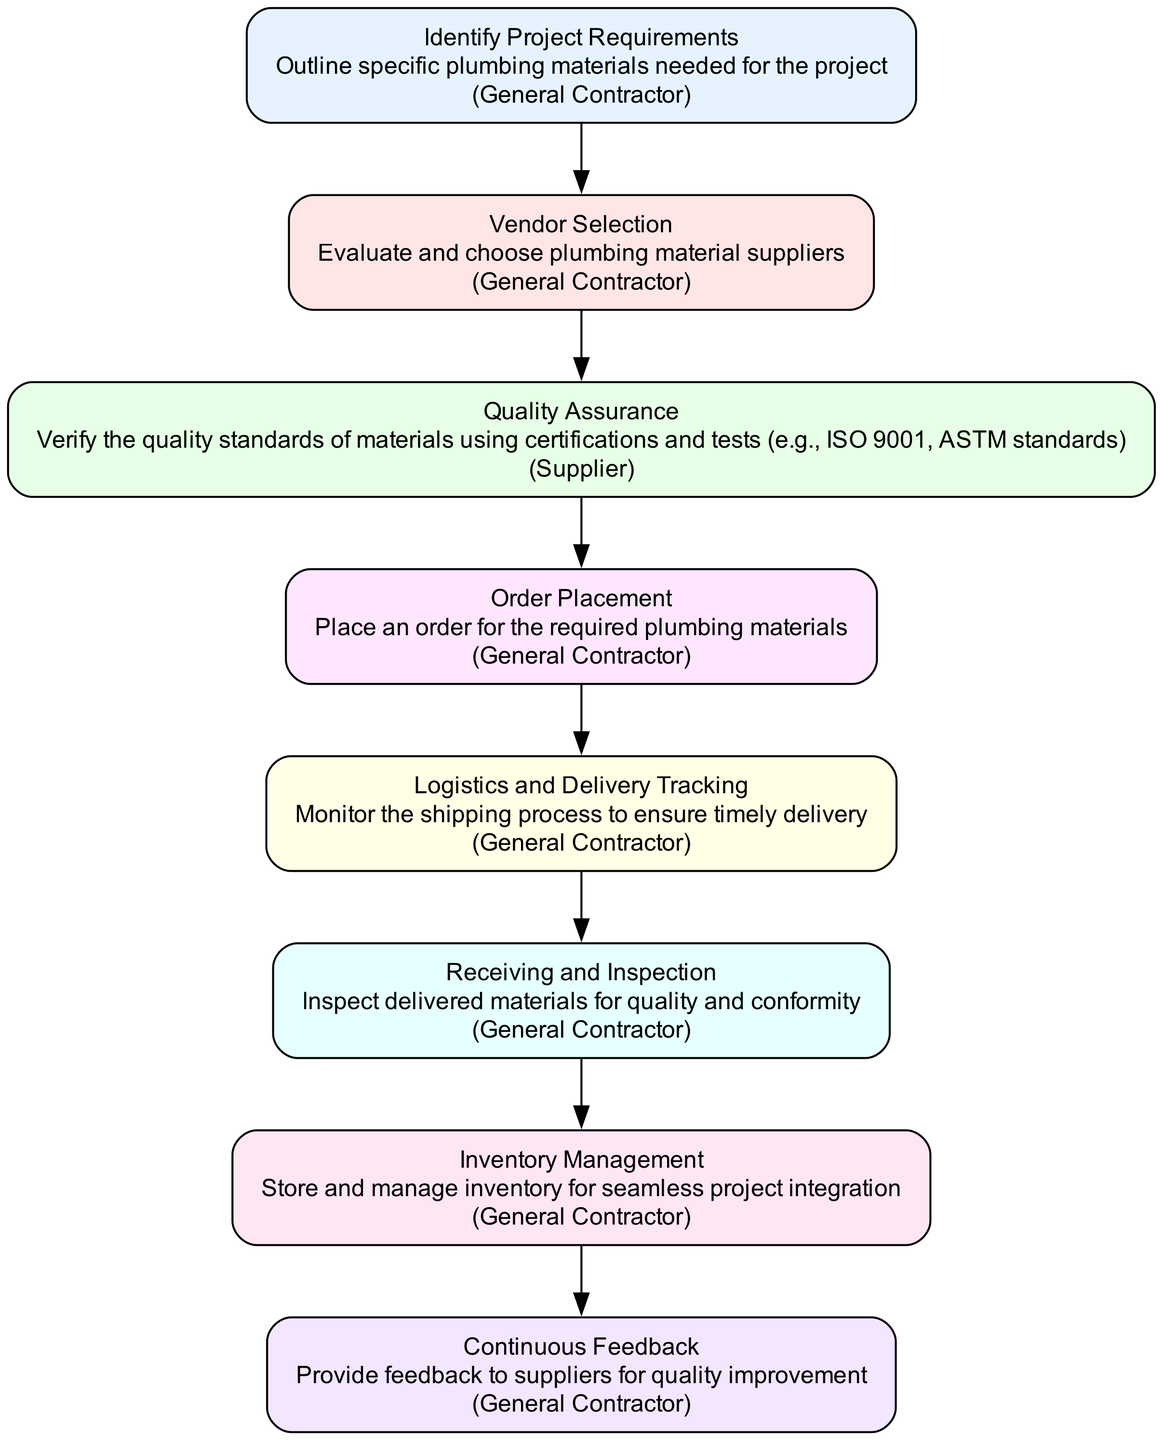What is the first step in the clinical pathway? The first step is labeled "Identify Project Requirements". It involves outlining specific plumbing materials needed for the project.
Answer: Identify Project Requirements Who is responsible for the "Quality Assurance" node? The "Quality Assurance" node is primarily the responsibility of the supplier, as indicated in the diagram.
Answer: Supplier How many nodes are in the clinical pathway? There are a total of eight nodes within the clinical pathway structure. Each node represents a specific part of the supply chain process.
Answer: 8 What connects the "Order Placement" node to the next in the sequence? The "Order Placement" node is followed by the "Logistics and Delivery Tracking" node, indicating the next step after placing an order.
Answer: Logistics and Delivery Tracking Which node involves inspecting materials? The node responsible for inspecting materials is labeled "Receiving and Inspection". This step emphasizes the importance of checking the quality and conformity of delivered materials.
Answer: Receiving and Inspection What node allows for feedback to suppliers? The node that allows for providing feedback to suppliers is "Continuous Feedback". This node ensures that there are channels for quality improvement discussions.
Answer: Continuous Feedback What is the relationship between "Vendor Selection" and "Quality Assurance"? The "Vendor Selection" node precedes the "Quality Assurance" node, indicating that selecting a vendor occurs before verifying material quality standards.
Answer: Vendor Selection → Quality Assurance Which node is responsible for tracking shipping? The node labeled "Logistics and Delivery Tracking" is responsible for monitoring the shipping process to ensure timely delivery of materials.
Answer: Logistics and Delivery Tracking What is the main purpose of the "Inventory Management" node? The "Inventory Management" node is for storing and managing inventory effectively to ensure seamless integration into the project.
Answer: Store and manage inventory 